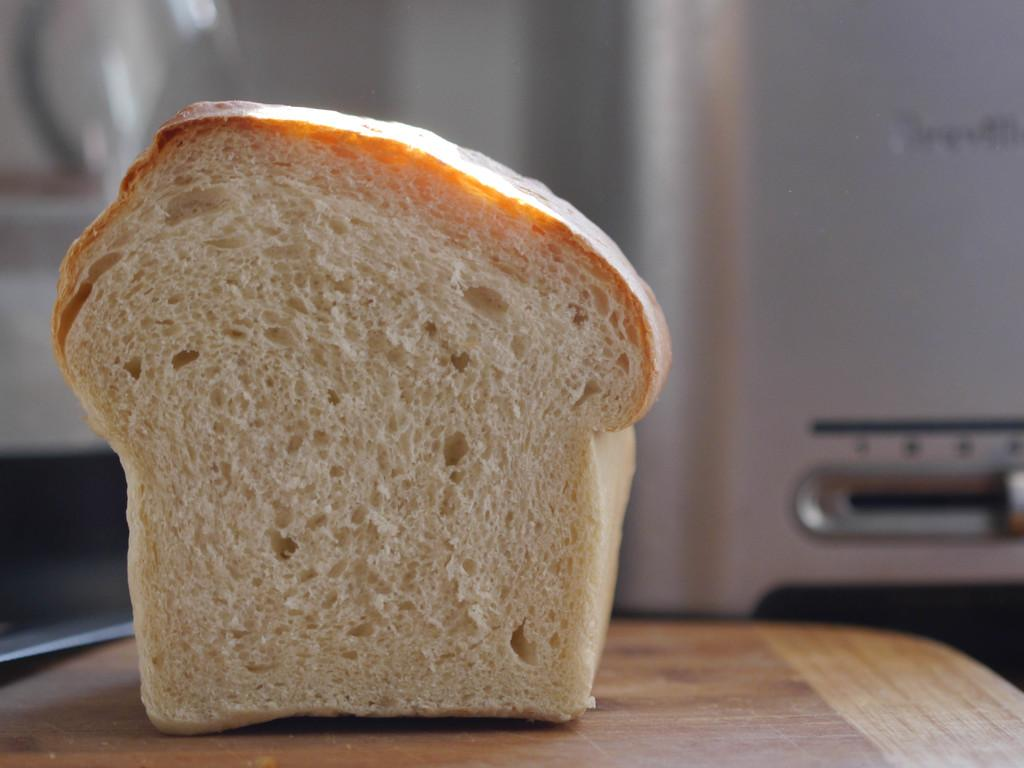What is placed on the wooden surface in the image? There is a bread on a wooden surface in the image. What else can be seen on the right side of the image? There appears to be an electronic device on the right side of the image. Can you describe the background of the image? The background of the image is blurry. What type of tent can be seen in the image? There is no tent present in the image. How many boots are visible in the image? There are no boots present in the image. 